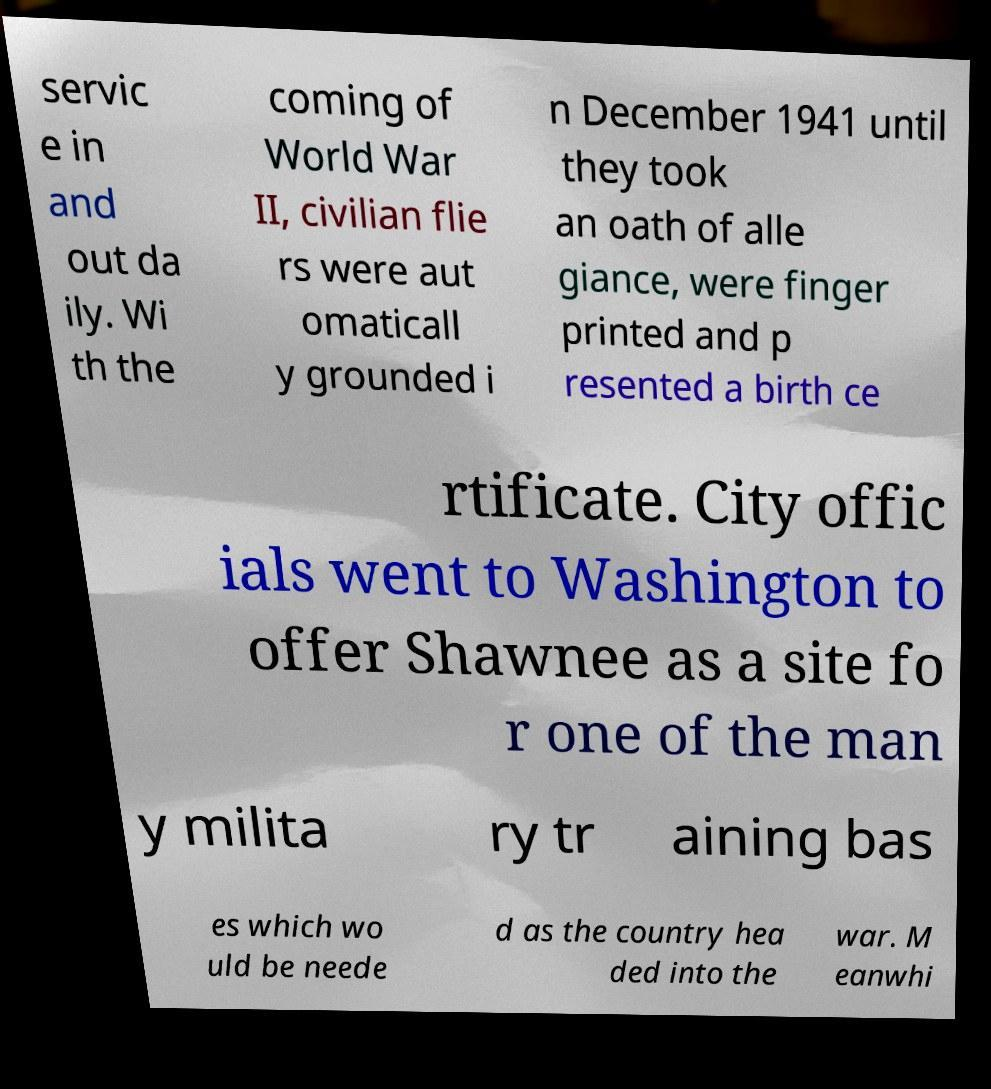Can you read and provide the text displayed in the image?This photo seems to have some interesting text. Can you extract and type it out for me? servic e in and out da ily. Wi th the coming of World War II, civilian flie rs were aut omaticall y grounded i n December 1941 until they took an oath of alle giance, were finger printed and p resented a birth ce rtificate. City offic ials went to Washington to offer Shawnee as a site fo r one of the man y milita ry tr aining bas es which wo uld be neede d as the country hea ded into the war. M eanwhi 